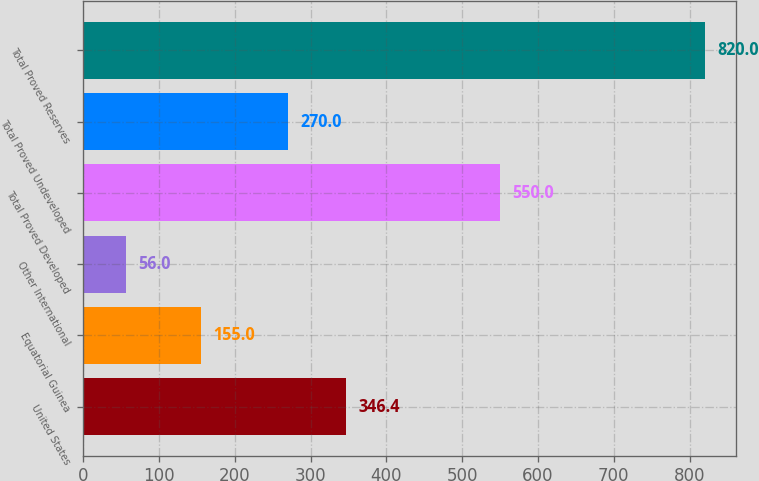Convert chart to OTSL. <chart><loc_0><loc_0><loc_500><loc_500><bar_chart><fcel>United States<fcel>Equatorial Guinea<fcel>Other International<fcel>Total Proved Developed<fcel>Total Proved Undeveloped<fcel>Total Proved Reserves<nl><fcel>346.4<fcel>155<fcel>56<fcel>550<fcel>270<fcel>820<nl></chart> 